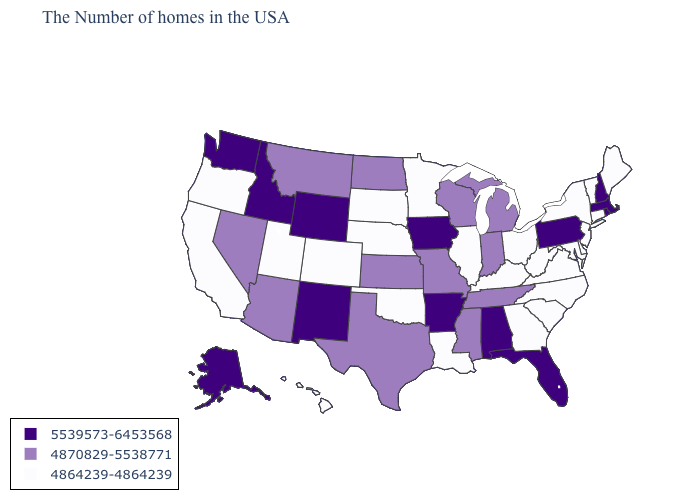What is the value of Alaska?
Quick response, please. 5539573-6453568. Name the states that have a value in the range 4864239-4864239?
Concise answer only. Maine, Vermont, Connecticut, New York, New Jersey, Delaware, Maryland, Virginia, North Carolina, South Carolina, West Virginia, Ohio, Georgia, Kentucky, Illinois, Louisiana, Minnesota, Nebraska, Oklahoma, South Dakota, Colorado, Utah, California, Oregon, Hawaii. What is the value of Georgia?
Write a very short answer. 4864239-4864239. Does the first symbol in the legend represent the smallest category?
Be succinct. No. Name the states that have a value in the range 4870829-5538771?
Keep it brief. Michigan, Indiana, Tennessee, Wisconsin, Mississippi, Missouri, Kansas, Texas, North Dakota, Montana, Arizona, Nevada. What is the lowest value in the West?
Give a very brief answer. 4864239-4864239. Does Kentucky have the lowest value in the South?
Give a very brief answer. Yes. Does Kansas have a higher value than Hawaii?
Keep it brief. Yes. What is the value of Minnesota?
Quick response, please. 4864239-4864239. Name the states that have a value in the range 5539573-6453568?
Write a very short answer. Massachusetts, Rhode Island, New Hampshire, Pennsylvania, Florida, Alabama, Arkansas, Iowa, Wyoming, New Mexico, Idaho, Washington, Alaska. What is the lowest value in states that border Louisiana?
Give a very brief answer. 4870829-5538771. Does South Dakota have the lowest value in the USA?
Give a very brief answer. Yes. What is the value of California?
Concise answer only. 4864239-4864239. Name the states that have a value in the range 4870829-5538771?
Be succinct. Michigan, Indiana, Tennessee, Wisconsin, Mississippi, Missouri, Kansas, Texas, North Dakota, Montana, Arizona, Nevada. What is the value of Kansas?
Be succinct. 4870829-5538771. 